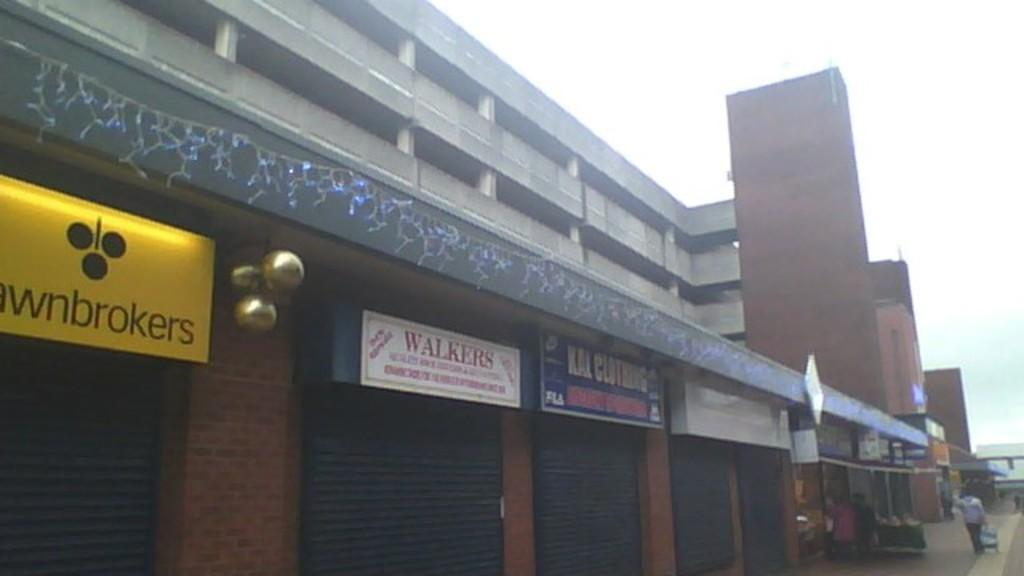What type of structure is present in the image? There is a building in the image. What feature can be seen on the building? The building has rolling shutters. Are there any additional elements on the building? Yes, the building has boards. What is visible at the top of the image? The sky is visible at the top of the image. Can you tell me how many people are arguing about the approval of the building in the image? There is no indication of an argument or approval process in the image; it simply shows a building with rolling shutters and boards. 